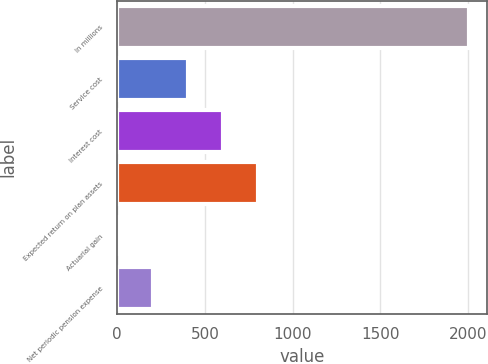Convert chart. <chart><loc_0><loc_0><loc_500><loc_500><bar_chart><fcel>In millions<fcel>Service cost<fcel>Interest cost<fcel>Expected return on plan assets<fcel>Actuarial gain<fcel>Net periodic pension expense<nl><fcel>2008<fcel>402.4<fcel>603.1<fcel>803.8<fcel>1<fcel>201.7<nl></chart> 